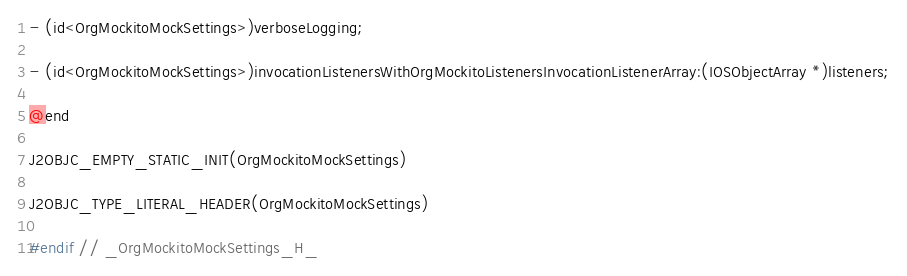Convert code to text. <code><loc_0><loc_0><loc_500><loc_500><_C_>- (id<OrgMockitoMockSettings>)verboseLogging;

- (id<OrgMockitoMockSettings>)invocationListenersWithOrgMockitoListenersInvocationListenerArray:(IOSObjectArray *)listeners;

@end

J2OBJC_EMPTY_STATIC_INIT(OrgMockitoMockSettings)

J2OBJC_TYPE_LITERAL_HEADER(OrgMockitoMockSettings)

#endif // _OrgMockitoMockSettings_H_
</code> 